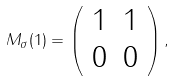<formula> <loc_0><loc_0><loc_500><loc_500>M _ { \sigma } ( 1 ) = \left ( \begin{array} { c c } 1 & 1 \\ 0 & 0 \end{array} \right ) ,</formula> 